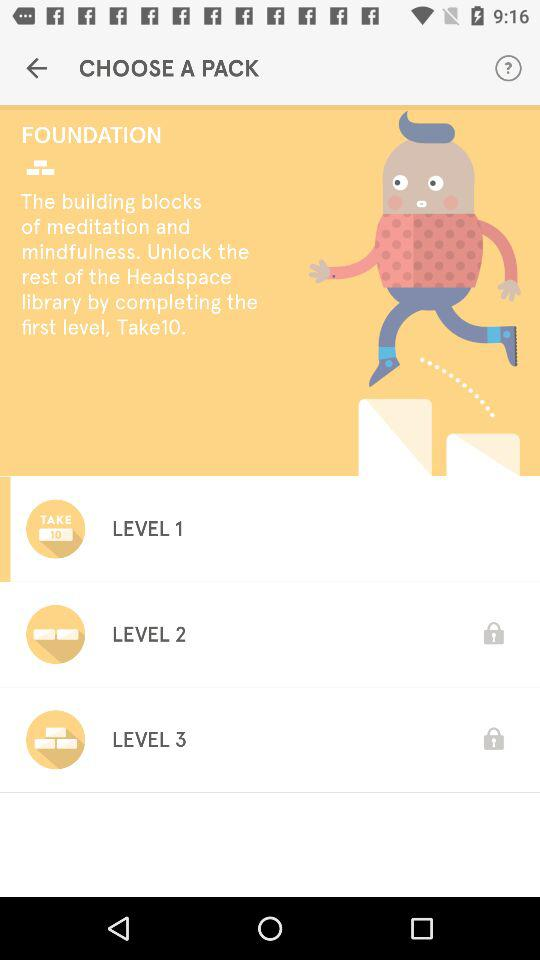How many levels are there in the Foundation pack?
Answer the question using a single word or phrase. 3 